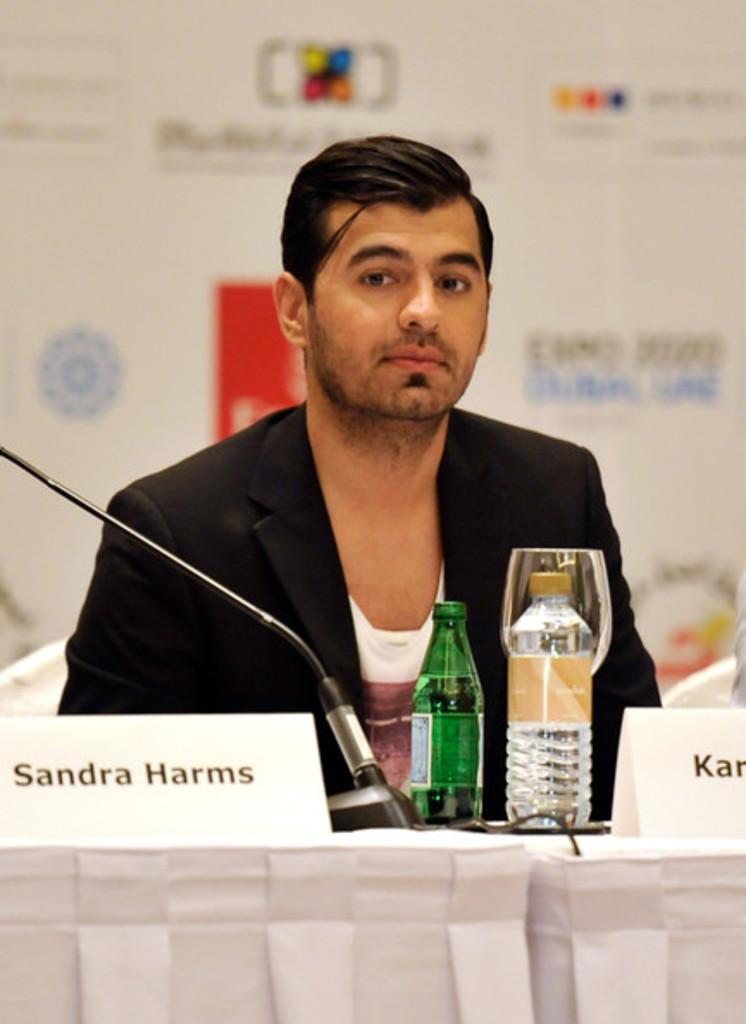What is the man in the image wearing? The man in the image is wearing a black suit. What objects can be seen on the table in the image? The table in the image has bottles visible on it. What is the background of the image? There is a hoarding in the background of the image. What type of plough is being used by the man in the image? There is no plough present in the image; the man is wearing a black suit. What kind of apparel is being requested by the man in the image? The man in the image is not making any requests, and there is no mention of apparel in the image. 